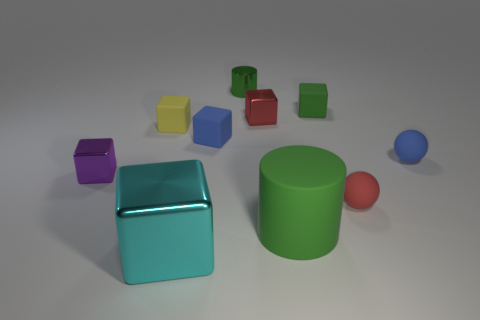Subtract all cyan cubes. How many cubes are left? 5 Subtract all small purple metal cubes. How many cubes are left? 5 Subtract all purple cubes. Subtract all yellow balls. How many cubes are left? 5 Subtract all cylinders. How many objects are left? 8 Subtract all small cyan metal cylinders. Subtract all red matte balls. How many objects are left? 9 Add 2 tiny cylinders. How many tiny cylinders are left? 3 Add 4 big matte objects. How many big matte objects exist? 5 Subtract 1 red balls. How many objects are left? 9 